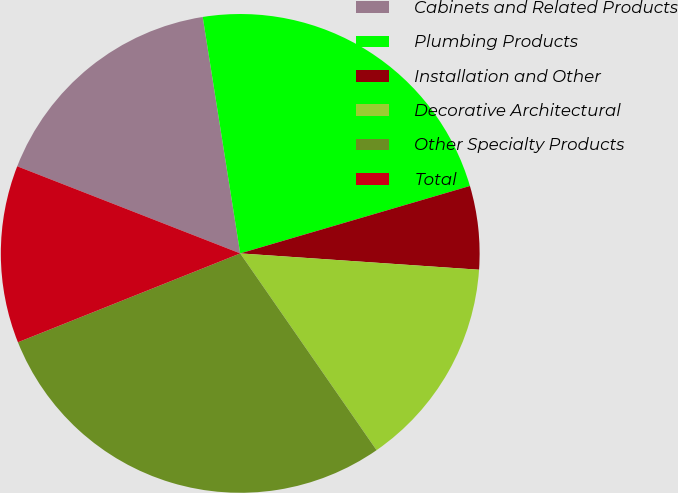Convert chart to OTSL. <chart><loc_0><loc_0><loc_500><loc_500><pie_chart><fcel>Cabinets and Related Products<fcel>Plumbing Products<fcel>Installation and Other<fcel>Decorative Architectural<fcel>Other Specialty Products<fcel>Total<nl><fcel>16.57%<fcel>22.96%<fcel>5.63%<fcel>14.27%<fcel>28.59%<fcel>11.98%<nl></chart> 